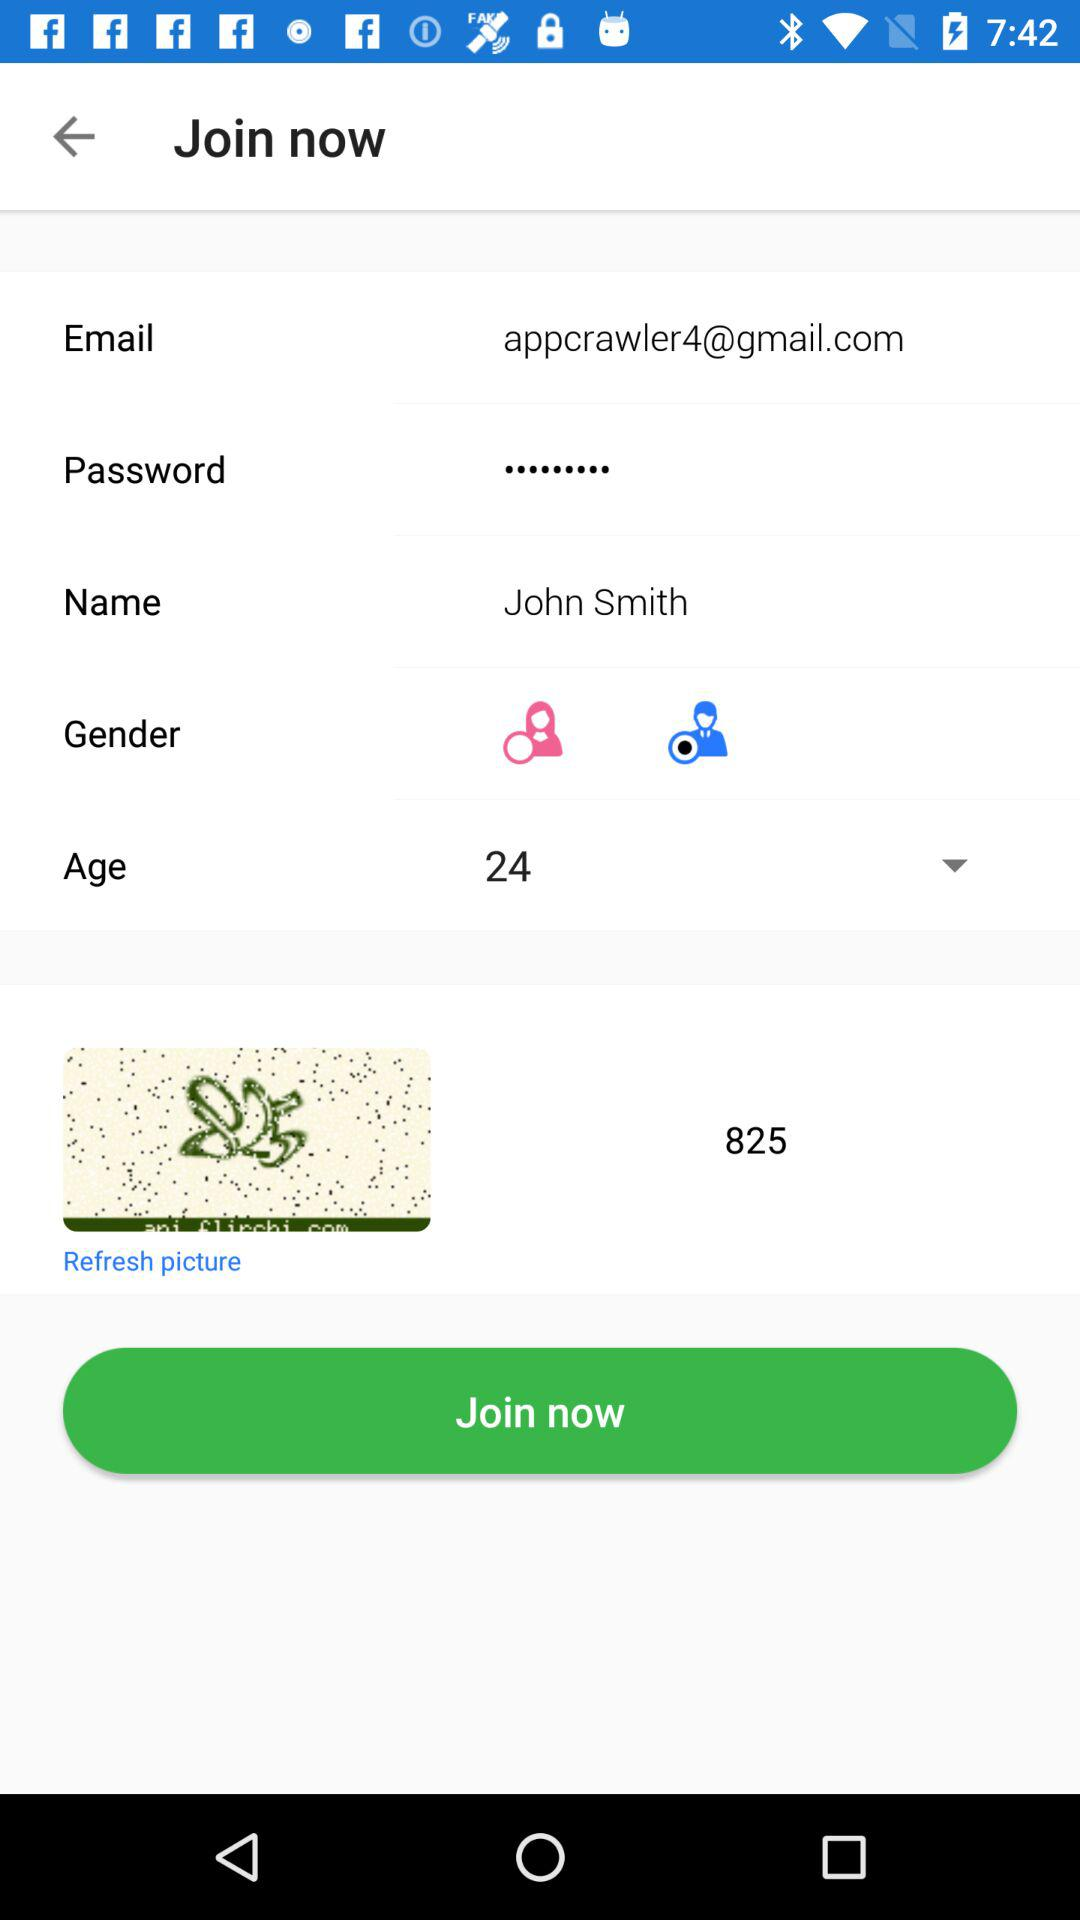What is the given name? The given name is John Smith. 